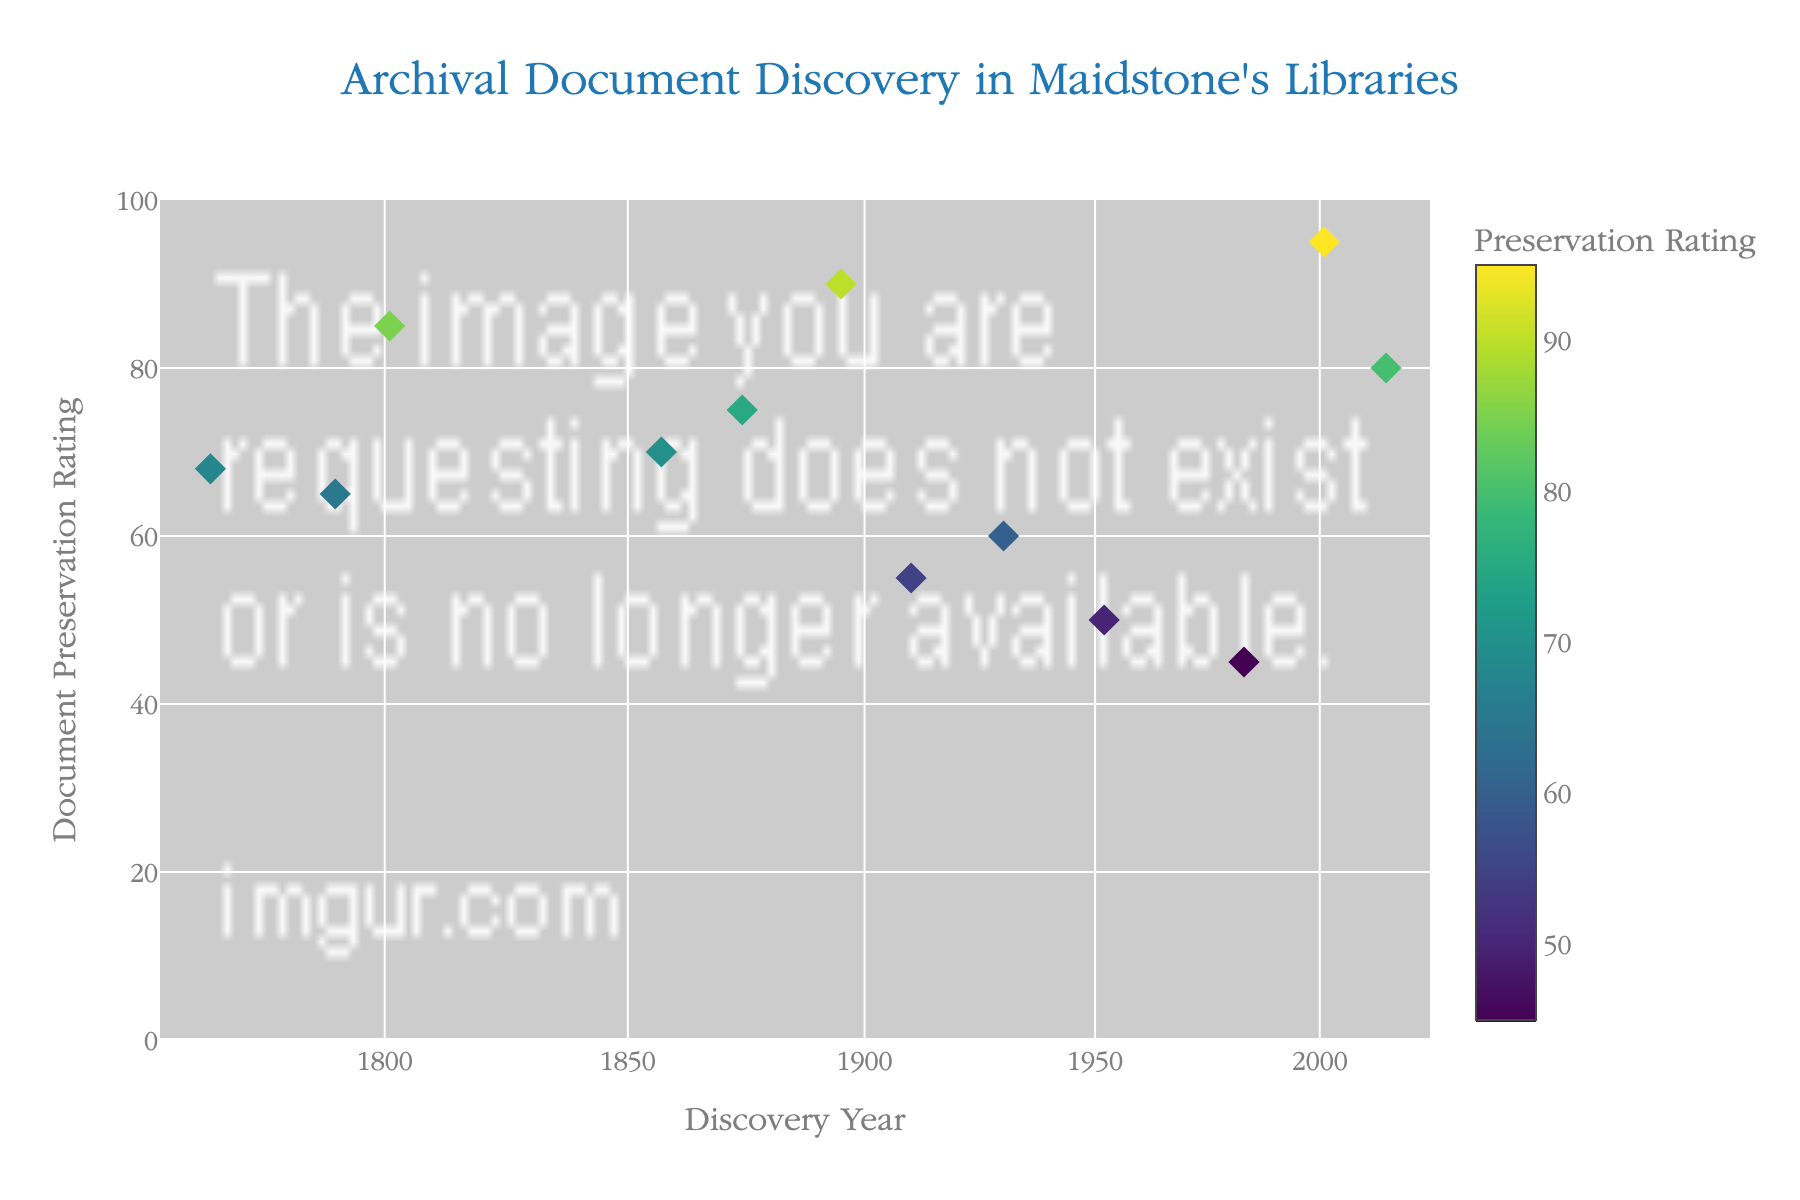What is the title of the plot? The title is prominently displayed at the top center of the figure.
Answer: Archival Document Discovery in Maidstone's Libraries What is the range of the 'Document Preservation Rating' axis? The y-axis is labeled "Document Preservation Rating" and ranges from 0 to 100.
Answer: 0 to 100 How many data points in total are displayed on the scatter plot? By counting the number of markers on the plot, we can determine the total number of data points. There are 12 markers.
Answer: 12 Which year has the highest 'Document Preservation Rating', and what is the rating? By examining the y-axis (Preservation Rating) values and looking for the highest point, you can see that the year with the highest rating is 2001, with a rating of 95.
Answer: 2001, 95 Which year has the lowest documented preservation rating, and what is the rating? By examining the y-axis values and identifying the lowest point, you can see that the year with the lowest rating is 1983, with a rating of 45.
Answer: 1983, 45 How many documents have a preservation rating above 80? By counting the number of markers positioned above the y=80 line, there are 3 documents (with ratings 85, 90, and 95).
Answer: 3 What is the average rating of documents discovered in the 20th century (1901-2000)? Identify the 20th-century data points (1910, 1930, 1952, 1983) and calculate the average: (55 + 60 + 50 + 45)/4 = 52.5.
Answer: 52.5 Is there a noticeable trend in the preservation ratings over time? By visually inspecting the scatter plot, you can see that there isn't a clear increasing or decreasing trend over time since the ratings fluctuate.
Answer: No clear trend Compare the preservation rating of documents discovered before 1800 to those discovered after 2000. Is there a difference in average ratings? Calculate the average for the documents before 1800 (years 1765 and 1790: (68+65)/2=66.5) and after 2000 (2001 and 2015: (95+80)/2=87.5). The average rating after 2000 is higher.
Answer: After 2000 is higher Why might a log scale be used for the 'Discovery Year' axis? A log scale is often used to handle a wide range of values in a more readable format, which allows for better visualization of data across different time periods.
Answer: To handle wide range of values 